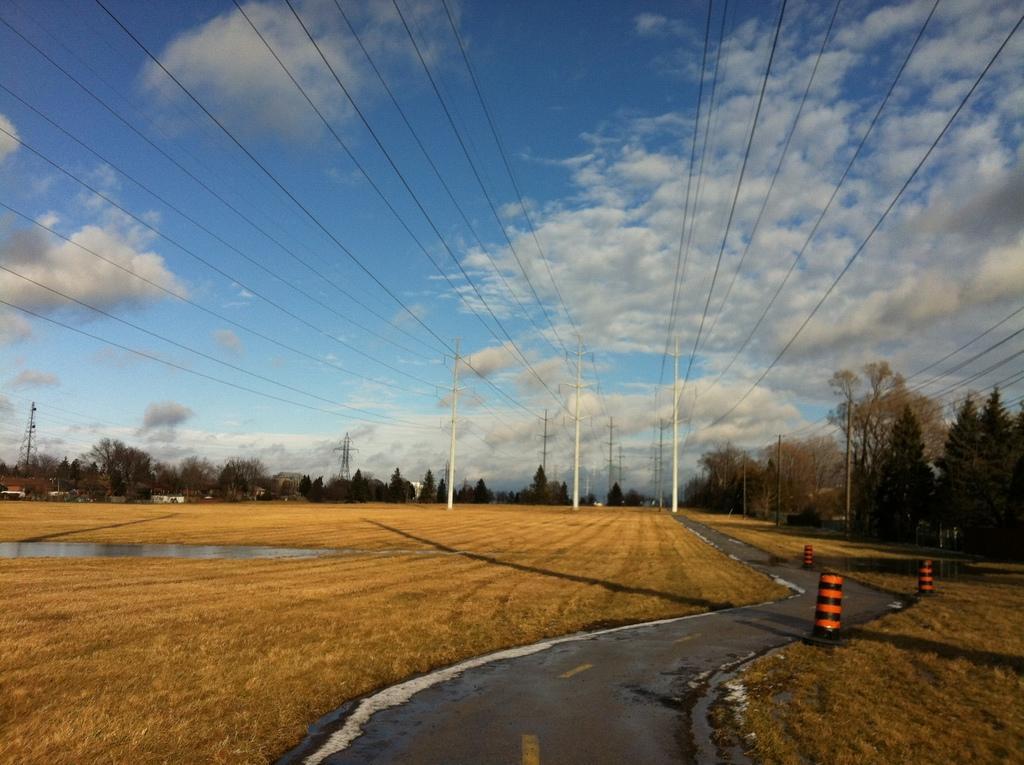Could you give a brief overview of what you see in this image? In this image, I can see the dried grass, current polls, trees, transmission towers, construction barriers and the road. These are the clouds in the sky. On the left side of the image, I can see the water. 